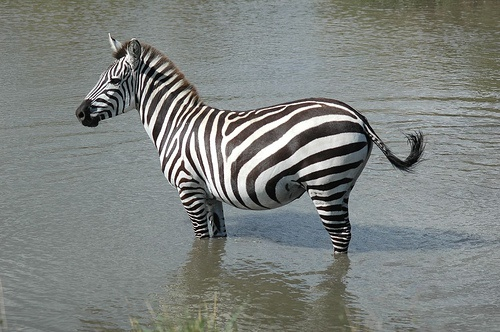Describe the objects in this image and their specific colors. I can see a zebra in gray, black, white, and darkgray tones in this image. 